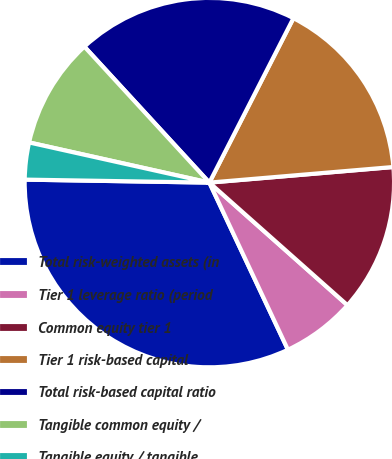Convert chart to OTSL. <chart><loc_0><loc_0><loc_500><loc_500><pie_chart><fcel>Total risk-weighted assets (in<fcel>Tier 1 leverage ratio (period<fcel>Common equity tier 1<fcel>Tier 1 risk-based capital<fcel>Total risk-based capital ratio<fcel>Tangible common equity /<fcel>Tangible equity / tangible<nl><fcel>32.25%<fcel>6.45%<fcel>12.9%<fcel>16.13%<fcel>19.35%<fcel>9.68%<fcel>3.23%<nl></chart> 